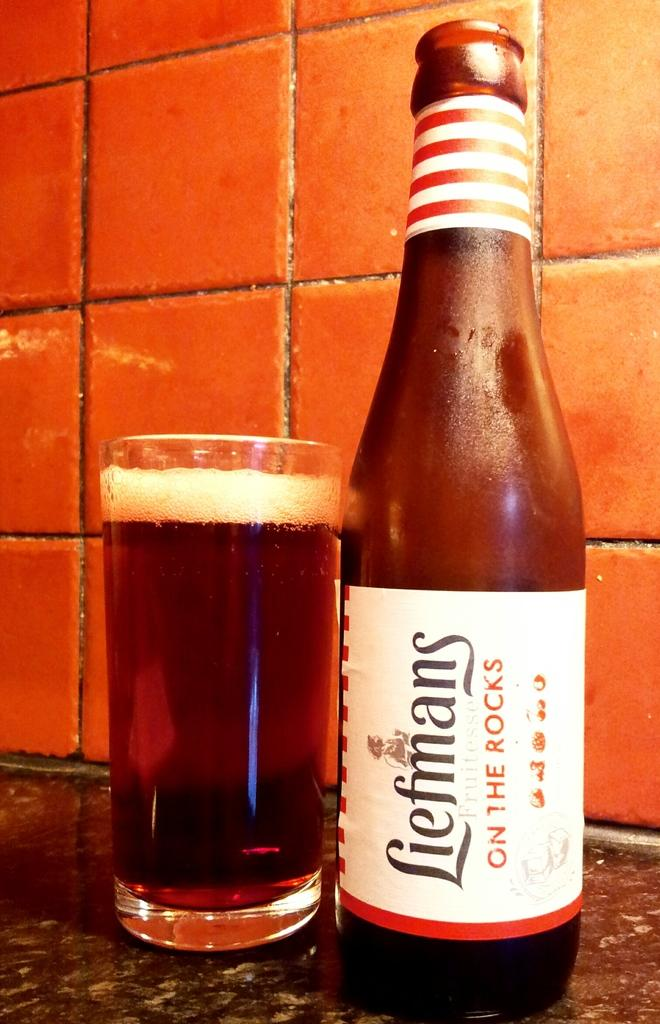<image>
Create a compact narrative representing the image presented. A bottle of Liefmans stands next to a full glass. 